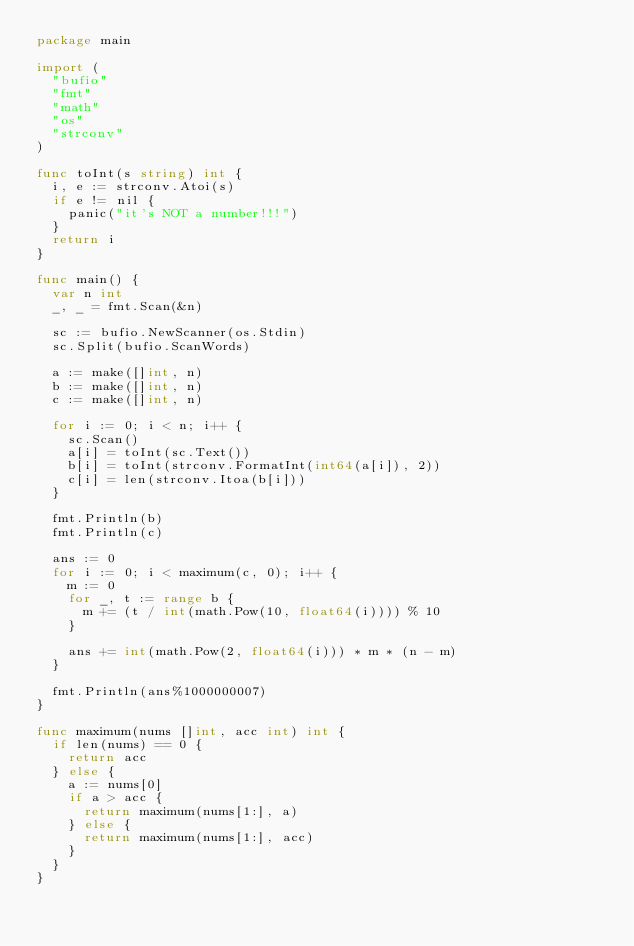Convert code to text. <code><loc_0><loc_0><loc_500><loc_500><_Go_>package main

import (
	"bufio"
	"fmt"
	"math"
	"os"
	"strconv"
)

func toInt(s string) int {
	i, e := strconv.Atoi(s)
	if e != nil {
		panic("it's NOT a number!!!")
	}
	return i
}

func main() {
	var n int
	_, _ = fmt.Scan(&n)
	
	sc := bufio.NewScanner(os.Stdin)
	sc.Split(bufio.ScanWords)
	
	a := make([]int, n)
	b := make([]int, n)
	c := make([]int, n)
	
	for i := 0; i < n; i++ {
		sc.Scan()
		a[i] = toInt(sc.Text())
		b[i] = toInt(strconv.FormatInt(int64(a[i]), 2))
		c[i] = len(strconv.Itoa(b[i]))
	}
	
	fmt.Println(b)
	fmt.Println(c)
	
	ans := 0
	for i := 0; i < maximum(c, 0); i++ {
		m := 0
		for _, t := range b {
			m += (t / int(math.Pow(10, float64(i)))) % 10
		}
		
		ans += int(math.Pow(2, float64(i))) * m * (n - m)
	}
	
	fmt.Println(ans%1000000007)
}

func maximum(nums []int, acc int) int {
	if len(nums) == 0 {
		return acc
	} else {
		a := nums[0]
		if a > acc {
			return maximum(nums[1:], a)
		} else {
			return maximum(nums[1:], acc)
		}
	}
}
</code> 